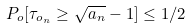Convert formula to latex. <formula><loc_0><loc_0><loc_500><loc_500>P _ { o } [ \tau _ { o _ { n } } \geq \sqrt { a _ { n } } - 1 ] \leq 1 / 2</formula> 